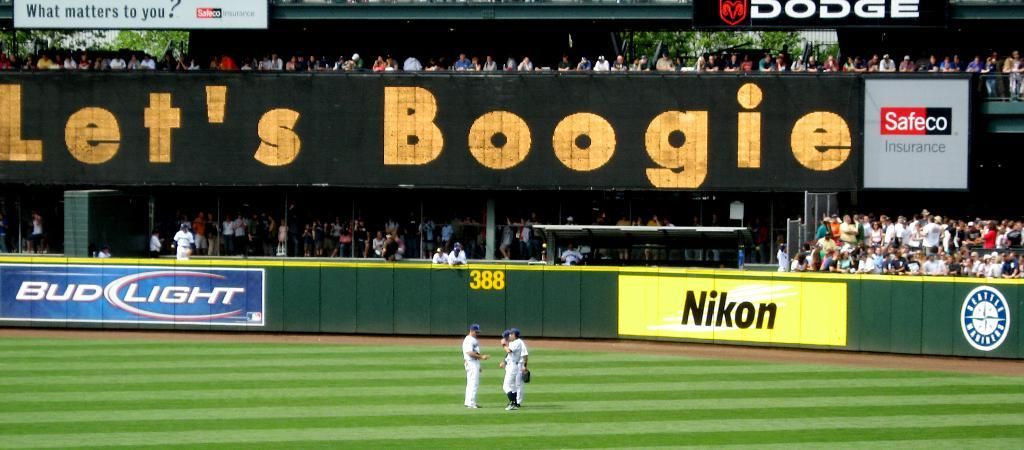<image>
Render a clear and concise summary of the photo. A baseball field with a Let's Boogie sign on it. 